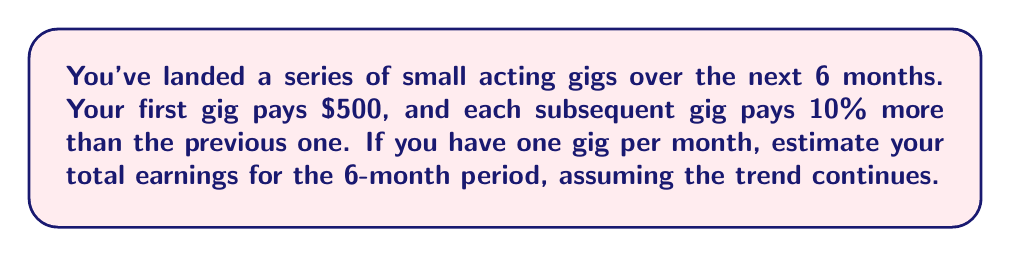Solve this math problem. Let's approach this step-by-step:

1) We're dealing with a geometric sequence where each term is 1.1 times the previous term (10% increase).

2) The first term, $a_1 = 500$.

3) The common ratio, $r = 1.1$.

4) We need to find the sum of 6 terms in this geometric sequence.

5) The formula for the sum of a geometric sequence is:

   $$S_n = \frac{a_1(1-r^n)}{1-r}$$

   where $S_n$ is the sum of $n$ terms, $a_1$ is the first term, and $r$ is the common ratio.

6) Plugging in our values:

   $$S_6 = \frac{500(1-1.1^6)}{1-1.1}$$

7) Let's calculate this:
   
   $$S_6 = \frac{500(1-1.771561)}{-0.1}$$
   
   $$S_6 = \frac{500(-0.771561)}{-0.1}$$
   
   $$S_6 = 3857.805$$

8) Rounding to the nearest dollar, we get $3,858.
Answer: $3,858 